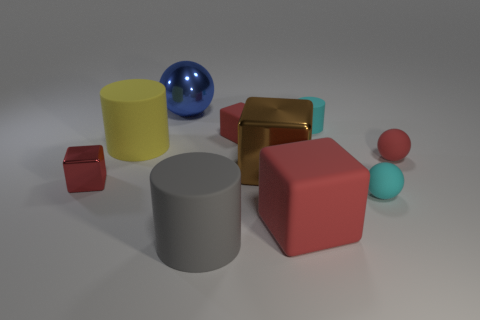How many red blocks must be subtracted to get 1 red blocks? 2 Subtract all red balls. How many red cubes are left? 3 Subtract all red balls. Subtract all gray cylinders. How many balls are left? 2 Subtract all cylinders. How many objects are left? 7 Subtract all tiny cyan metal objects. Subtract all cyan rubber cylinders. How many objects are left? 9 Add 6 red shiny things. How many red shiny things are left? 7 Add 6 small red rubber objects. How many small red rubber objects exist? 8 Subtract 1 red spheres. How many objects are left? 9 